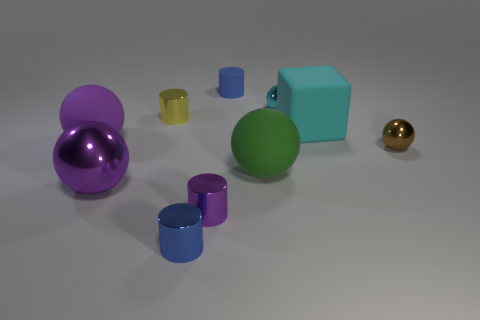Subtract all purple metallic cylinders. How many cylinders are left? 3 Subtract all purple balls. How many balls are left? 3 Subtract all brown spheres. Subtract all red cubes. How many spheres are left? 4 Subtract all cylinders. How many objects are left? 6 Add 3 purple things. How many purple things are left? 6 Add 6 large green spheres. How many large green spheres exist? 7 Subtract 0 purple blocks. How many objects are left? 10 Subtract all small purple metallic cylinders. Subtract all big cyan blocks. How many objects are left? 8 